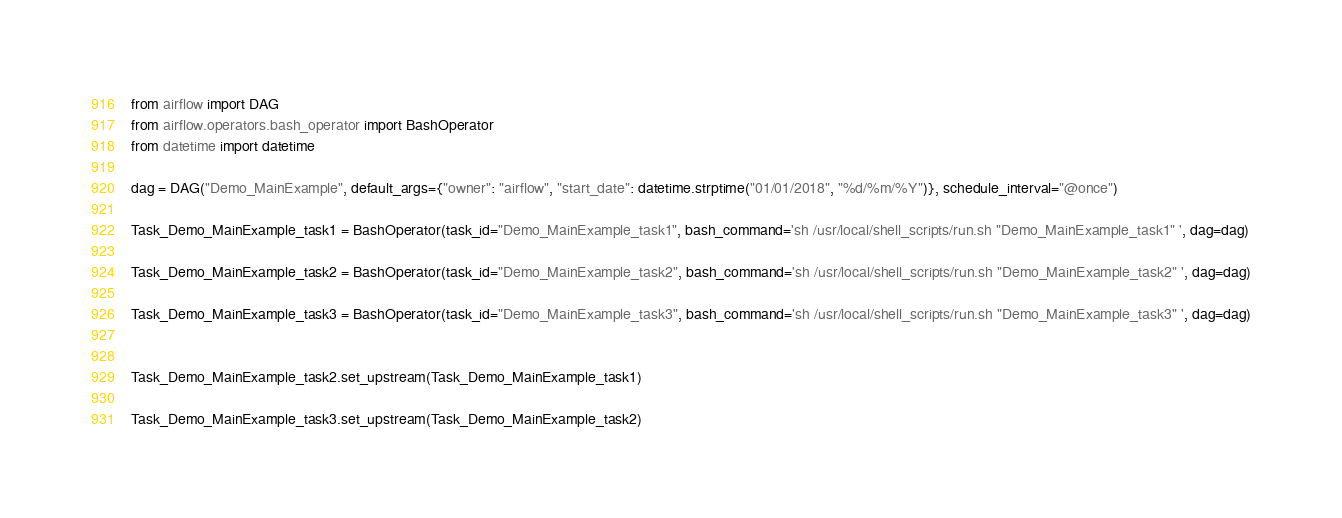Convert code to text. <code><loc_0><loc_0><loc_500><loc_500><_Python_>from airflow import DAG
from airflow.operators.bash_operator import BashOperator
from datetime import datetime

dag = DAG("Demo_MainExample", default_args={"owner": "airflow", "start_date": datetime.strptime("01/01/2018", "%d/%m/%Y")}, schedule_interval="@once")

Task_Demo_MainExample_task1 = BashOperator(task_id="Demo_MainExample_task1", bash_command='sh /usr/local/shell_scripts/run.sh "Demo_MainExample_task1" ', dag=dag)

Task_Demo_MainExample_task2 = BashOperator(task_id="Demo_MainExample_task2", bash_command='sh /usr/local/shell_scripts/run.sh "Demo_MainExample_task2" ', dag=dag)

Task_Demo_MainExample_task3 = BashOperator(task_id="Demo_MainExample_task3", bash_command='sh /usr/local/shell_scripts/run.sh "Demo_MainExample_task3" ', dag=dag)


Task_Demo_MainExample_task2.set_upstream(Task_Demo_MainExample_task1)

Task_Demo_MainExample_task3.set_upstream(Task_Demo_MainExample_task2)
</code> 